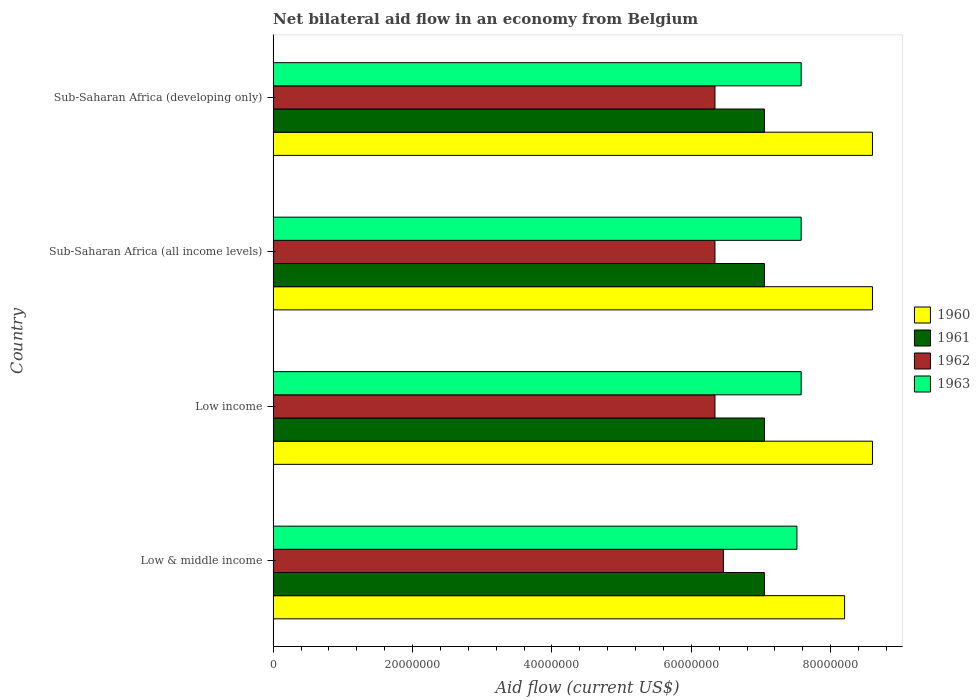How many different coloured bars are there?
Offer a terse response. 4. Are the number of bars per tick equal to the number of legend labels?
Offer a very short reply. Yes. Are the number of bars on each tick of the Y-axis equal?
Provide a succinct answer. Yes. How many bars are there on the 4th tick from the top?
Make the answer very short. 4. What is the label of the 1st group of bars from the top?
Your answer should be very brief. Sub-Saharan Africa (developing only). What is the net bilateral aid flow in 1961 in Low & middle income?
Provide a succinct answer. 7.05e+07. Across all countries, what is the maximum net bilateral aid flow in 1961?
Your response must be concise. 7.05e+07. Across all countries, what is the minimum net bilateral aid flow in 1960?
Offer a terse response. 8.20e+07. In which country was the net bilateral aid flow in 1962 maximum?
Provide a succinct answer. Low & middle income. In which country was the net bilateral aid flow in 1960 minimum?
Provide a succinct answer. Low & middle income. What is the total net bilateral aid flow in 1961 in the graph?
Your answer should be very brief. 2.82e+08. What is the difference between the net bilateral aid flow in 1961 in Low & middle income and that in Sub-Saharan Africa (all income levels)?
Your answer should be compact. 0. What is the difference between the net bilateral aid flow in 1961 in Low income and the net bilateral aid flow in 1962 in Low & middle income?
Make the answer very short. 5.89e+06. What is the average net bilateral aid flow in 1963 per country?
Make the answer very short. 7.56e+07. What is the difference between the net bilateral aid flow in 1962 and net bilateral aid flow in 1961 in Sub-Saharan Africa (all income levels)?
Give a very brief answer. -7.10e+06. What is the ratio of the net bilateral aid flow in 1963 in Low & middle income to that in Sub-Saharan Africa (developing only)?
Your response must be concise. 0.99. Is the net bilateral aid flow in 1962 in Sub-Saharan Africa (all income levels) less than that in Sub-Saharan Africa (developing only)?
Keep it short and to the point. No. Is the difference between the net bilateral aid flow in 1962 in Low income and Sub-Saharan Africa (developing only) greater than the difference between the net bilateral aid flow in 1961 in Low income and Sub-Saharan Africa (developing only)?
Make the answer very short. No. What is the difference between the highest and the second highest net bilateral aid flow in 1962?
Offer a terse response. 1.21e+06. What is the difference between the highest and the lowest net bilateral aid flow in 1961?
Make the answer very short. 0. In how many countries, is the net bilateral aid flow in 1961 greater than the average net bilateral aid flow in 1961 taken over all countries?
Offer a terse response. 0. Is the sum of the net bilateral aid flow in 1960 in Low income and Sub-Saharan Africa (all income levels) greater than the maximum net bilateral aid flow in 1961 across all countries?
Keep it short and to the point. Yes. Is it the case that in every country, the sum of the net bilateral aid flow in 1963 and net bilateral aid flow in 1961 is greater than the net bilateral aid flow in 1960?
Your answer should be very brief. Yes. How many bars are there?
Offer a very short reply. 16. How many countries are there in the graph?
Offer a terse response. 4. Does the graph contain any zero values?
Ensure brevity in your answer.  No. Does the graph contain grids?
Ensure brevity in your answer.  No. Where does the legend appear in the graph?
Provide a short and direct response. Center right. How are the legend labels stacked?
Your answer should be very brief. Vertical. What is the title of the graph?
Your answer should be very brief. Net bilateral aid flow in an economy from Belgium. Does "1970" appear as one of the legend labels in the graph?
Your response must be concise. No. What is the label or title of the X-axis?
Give a very brief answer. Aid flow (current US$). What is the Aid flow (current US$) of 1960 in Low & middle income?
Keep it short and to the point. 8.20e+07. What is the Aid flow (current US$) in 1961 in Low & middle income?
Make the answer very short. 7.05e+07. What is the Aid flow (current US$) in 1962 in Low & middle income?
Your answer should be very brief. 6.46e+07. What is the Aid flow (current US$) of 1963 in Low & middle income?
Keep it short and to the point. 7.52e+07. What is the Aid flow (current US$) in 1960 in Low income?
Make the answer very short. 8.60e+07. What is the Aid flow (current US$) of 1961 in Low income?
Make the answer very short. 7.05e+07. What is the Aid flow (current US$) of 1962 in Low income?
Offer a terse response. 6.34e+07. What is the Aid flow (current US$) of 1963 in Low income?
Keep it short and to the point. 7.58e+07. What is the Aid flow (current US$) of 1960 in Sub-Saharan Africa (all income levels)?
Your answer should be very brief. 8.60e+07. What is the Aid flow (current US$) in 1961 in Sub-Saharan Africa (all income levels)?
Give a very brief answer. 7.05e+07. What is the Aid flow (current US$) of 1962 in Sub-Saharan Africa (all income levels)?
Your response must be concise. 6.34e+07. What is the Aid flow (current US$) of 1963 in Sub-Saharan Africa (all income levels)?
Your response must be concise. 7.58e+07. What is the Aid flow (current US$) of 1960 in Sub-Saharan Africa (developing only)?
Ensure brevity in your answer.  8.60e+07. What is the Aid flow (current US$) of 1961 in Sub-Saharan Africa (developing only)?
Provide a short and direct response. 7.05e+07. What is the Aid flow (current US$) of 1962 in Sub-Saharan Africa (developing only)?
Ensure brevity in your answer.  6.34e+07. What is the Aid flow (current US$) of 1963 in Sub-Saharan Africa (developing only)?
Make the answer very short. 7.58e+07. Across all countries, what is the maximum Aid flow (current US$) in 1960?
Make the answer very short. 8.60e+07. Across all countries, what is the maximum Aid flow (current US$) of 1961?
Your answer should be very brief. 7.05e+07. Across all countries, what is the maximum Aid flow (current US$) of 1962?
Provide a short and direct response. 6.46e+07. Across all countries, what is the maximum Aid flow (current US$) in 1963?
Make the answer very short. 7.58e+07. Across all countries, what is the minimum Aid flow (current US$) in 1960?
Offer a terse response. 8.20e+07. Across all countries, what is the minimum Aid flow (current US$) of 1961?
Keep it short and to the point. 7.05e+07. Across all countries, what is the minimum Aid flow (current US$) in 1962?
Ensure brevity in your answer.  6.34e+07. Across all countries, what is the minimum Aid flow (current US$) of 1963?
Keep it short and to the point. 7.52e+07. What is the total Aid flow (current US$) in 1960 in the graph?
Ensure brevity in your answer.  3.40e+08. What is the total Aid flow (current US$) of 1961 in the graph?
Give a very brief answer. 2.82e+08. What is the total Aid flow (current US$) in 1962 in the graph?
Your response must be concise. 2.55e+08. What is the total Aid flow (current US$) of 1963 in the graph?
Your response must be concise. 3.02e+08. What is the difference between the Aid flow (current US$) of 1962 in Low & middle income and that in Low income?
Offer a very short reply. 1.21e+06. What is the difference between the Aid flow (current US$) in 1963 in Low & middle income and that in Low income?
Provide a short and direct response. -6.10e+05. What is the difference between the Aid flow (current US$) in 1960 in Low & middle income and that in Sub-Saharan Africa (all income levels)?
Ensure brevity in your answer.  -4.00e+06. What is the difference between the Aid flow (current US$) of 1962 in Low & middle income and that in Sub-Saharan Africa (all income levels)?
Make the answer very short. 1.21e+06. What is the difference between the Aid flow (current US$) in 1963 in Low & middle income and that in Sub-Saharan Africa (all income levels)?
Your answer should be compact. -6.10e+05. What is the difference between the Aid flow (current US$) of 1960 in Low & middle income and that in Sub-Saharan Africa (developing only)?
Provide a short and direct response. -4.00e+06. What is the difference between the Aid flow (current US$) of 1961 in Low & middle income and that in Sub-Saharan Africa (developing only)?
Your response must be concise. 0. What is the difference between the Aid flow (current US$) in 1962 in Low & middle income and that in Sub-Saharan Africa (developing only)?
Your answer should be very brief. 1.21e+06. What is the difference between the Aid flow (current US$) of 1963 in Low & middle income and that in Sub-Saharan Africa (developing only)?
Give a very brief answer. -6.10e+05. What is the difference between the Aid flow (current US$) in 1960 in Low income and that in Sub-Saharan Africa (all income levels)?
Your answer should be very brief. 0. What is the difference between the Aid flow (current US$) in 1961 in Low income and that in Sub-Saharan Africa (all income levels)?
Offer a terse response. 0. What is the difference between the Aid flow (current US$) of 1962 in Low income and that in Sub-Saharan Africa (all income levels)?
Your answer should be compact. 0. What is the difference between the Aid flow (current US$) in 1960 in Low income and that in Sub-Saharan Africa (developing only)?
Your response must be concise. 0. What is the difference between the Aid flow (current US$) in 1961 in Low income and that in Sub-Saharan Africa (developing only)?
Your answer should be very brief. 0. What is the difference between the Aid flow (current US$) in 1963 in Low income and that in Sub-Saharan Africa (developing only)?
Your response must be concise. 0. What is the difference between the Aid flow (current US$) of 1960 in Sub-Saharan Africa (all income levels) and that in Sub-Saharan Africa (developing only)?
Your response must be concise. 0. What is the difference between the Aid flow (current US$) in 1960 in Low & middle income and the Aid flow (current US$) in 1961 in Low income?
Provide a short and direct response. 1.15e+07. What is the difference between the Aid flow (current US$) in 1960 in Low & middle income and the Aid flow (current US$) in 1962 in Low income?
Provide a succinct answer. 1.86e+07. What is the difference between the Aid flow (current US$) in 1960 in Low & middle income and the Aid flow (current US$) in 1963 in Low income?
Offer a terse response. 6.23e+06. What is the difference between the Aid flow (current US$) in 1961 in Low & middle income and the Aid flow (current US$) in 1962 in Low income?
Provide a succinct answer. 7.10e+06. What is the difference between the Aid flow (current US$) of 1961 in Low & middle income and the Aid flow (current US$) of 1963 in Low income?
Your answer should be very brief. -5.27e+06. What is the difference between the Aid flow (current US$) in 1962 in Low & middle income and the Aid flow (current US$) in 1963 in Low income?
Offer a terse response. -1.12e+07. What is the difference between the Aid flow (current US$) of 1960 in Low & middle income and the Aid flow (current US$) of 1961 in Sub-Saharan Africa (all income levels)?
Your response must be concise. 1.15e+07. What is the difference between the Aid flow (current US$) of 1960 in Low & middle income and the Aid flow (current US$) of 1962 in Sub-Saharan Africa (all income levels)?
Provide a short and direct response. 1.86e+07. What is the difference between the Aid flow (current US$) of 1960 in Low & middle income and the Aid flow (current US$) of 1963 in Sub-Saharan Africa (all income levels)?
Ensure brevity in your answer.  6.23e+06. What is the difference between the Aid flow (current US$) in 1961 in Low & middle income and the Aid flow (current US$) in 1962 in Sub-Saharan Africa (all income levels)?
Ensure brevity in your answer.  7.10e+06. What is the difference between the Aid flow (current US$) of 1961 in Low & middle income and the Aid flow (current US$) of 1963 in Sub-Saharan Africa (all income levels)?
Your answer should be compact. -5.27e+06. What is the difference between the Aid flow (current US$) of 1962 in Low & middle income and the Aid flow (current US$) of 1963 in Sub-Saharan Africa (all income levels)?
Your answer should be very brief. -1.12e+07. What is the difference between the Aid flow (current US$) of 1960 in Low & middle income and the Aid flow (current US$) of 1961 in Sub-Saharan Africa (developing only)?
Offer a terse response. 1.15e+07. What is the difference between the Aid flow (current US$) of 1960 in Low & middle income and the Aid flow (current US$) of 1962 in Sub-Saharan Africa (developing only)?
Your answer should be compact. 1.86e+07. What is the difference between the Aid flow (current US$) in 1960 in Low & middle income and the Aid flow (current US$) in 1963 in Sub-Saharan Africa (developing only)?
Keep it short and to the point. 6.23e+06. What is the difference between the Aid flow (current US$) of 1961 in Low & middle income and the Aid flow (current US$) of 1962 in Sub-Saharan Africa (developing only)?
Provide a short and direct response. 7.10e+06. What is the difference between the Aid flow (current US$) of 1961 in Low & middle income and the Aid flow (current US$) of 1963 in Sub-Saharan Africa (developing only)?
Offer a terse response. -5.27e+06. What is the difference between the Aid flow (current US$) of 1962 in Low & middle income and the Aid flow (current US$) of 1963 in Sub-Saharan Africa (developing only)?
Your response must be concise. -1.12e+07. What is the difference between the Aid flow (current US$) in 1960 in Low income and the Aid flow (current US$) in 1961 in Sub-Saharan Africa (all income levels)?
Offer a terse response. 1.55e+07. What is the difference between the Aid flow (current US$) of 1960 in Low income and the Aid flow (current US$) of 1962 in Sub-Saharan Africa (all income levels)?
Make the answer very short. 2.26e+07. What is the difference between the Aid flow (current US$) in 1960 in Low income and the Aid flow (current US$) in 1963 in Sub-Saharan Africa (all income levels)?
Your answer should be very brief. 1.02e+07. What is the difference between the Aid flow (current US$) of 1961 in Low income and the Aid flow (current US$) of 1962 in Sub-Saharan Africa (all income levels)?
Provide a short and direct response. 7.10e+06. What is the difference between the Aid flow (current US$) in 1961 in Low income and the Aid flow (current US$) in 1963 in Sub-Saharan Africa (all income levels)?
Provide a short and direct response. -5.27e+06. What is the difference between the Aid flow (current US$) of 1962 in Low income and the Aid flow (current US$) of 1963 in Sub-Saharan Africa (all income levels)?
Make the answer very short. -1.24e+07. What is the difference between the Aid flow (current US$) in 1960 in Low income and the Aid flow (current US$) in 1961 in Sub-Saharan Africa (developing only)?
Make the answer very short. 1.55e+07. What is the difference between the Aid flow (current US$) of 1960 in Low income and the Aid flow (current US$) of 1962 in Sub-Saharan Africa (developing only)?
Provide a succinct answer. 2.26e+07. What is the difference between the Aid flow (current US$) in 1960 in Low income and the Aid flow (current US$) in 1963 in Sub-Saharan Africa (developing only)?
Keep it short and to the point. 1.02e+07. What is the difference between the Aid flow (current US$) of 1961 in Low income and the Aid flow (current US$) of 1962 in Sub-Saharan Africa (developing only)?
Ensure brevity in your answer.  7.10e+06. What is the difference between the Aid flow (current US$) in 1961 in Low income and the Aid flow (current US$) in 1963 in Sub-Saharan Africa (developing only)?
Provide a short and direct response. -5.27e+06. What is the difference between the Aid flow (current US$) in 1962 in Low income and the Aid flow (current US$) in 1963 in Sub-Saharan Africa (developing only)?
Your answer should be very brief. -1.24e+07. What is the difference between the Aid flow (current US$) in 1960 in Sub-Saharan Africa (all income levels) and the Aid flow (current US$) in 1961 in Sub-Saharan Africa (developing only)?
Offer a very short reply. 1.55e+07. What is the difference between the Aid flow (current US$) in 1960 in Sub-Saharan Africa (all income levels) and the Aid flow (current US$) in 1962 in Sub-Saharan Africa (developing only)?
Your response must be concise. 2.26e+07. What is the difference between the Aid flow (current US$) in 1960 in Sub-Saharan Africa (all income levels) and the Aid flow (current US$) in 1963 in Sub-Saharan Africa (developing only)?
Give a very brief answer. 1.02e+07. What is the difference between the Aid flow (current US$) in 1961 in Sub-Saharan Africa (all income levels) and the Aid flow (current US$) in 1962 in Sub-Saharan Africa (developing only)?
Your answer should be very brief. 7.10e+06. What is the difference between the Aid flow (current US$) of 1961 in Sub-Saharan Africa (all income levels) and the Aid flow (current US$) of 1963 in Sub-Saharan Africa (developing only)?
Offer a terse response. -5.27e+06. What is the difference between the Aid flow (current US$) in 1962 in Sub-Saharan Africa (all income levels) and the Aid flow (current US$) in 1963 in Sub-Saharan Africa (developing only)?
Ensure brevity in your answer.  -1.24e+07. What is the average Aid flow (current US$) in 1960 per country?
Ensure brevity in your answer.  8.50e+07. What is the average Aid flow (current US$) of 1961 per country?
Your answer should be compact. 7.05e+07. What is the average Aid flow (current US$) in 1962 per country?
Your response must be concise. 6.37e+07. What is the average Aid flow (current US$) in 1963 per country?
Ensure brevity in your answer.  7.56e+07. What is the difference between the Aid flow (current US$) of 1960 and Aid flow (current US$) of 1961 in Low & middle income?
Provide a succinct answer. 1.15e+07. What is the difference between the Aid flow (current US$) of 1960 and Aid flow (current US$) of 1962 in Low & middle income?
Your answer should be compact. 1.74e+07. What is the difference between the Aid flow (current US$) of 1960 and Aid flow (current US$) of 1963 in Low & middle income?
Offer a terse response. 6.84e+06. What is the difference between the Aid flow (current US$) in 1961 and Aid flow (current US$) in 1962 in Low & middle income?
Keep it short and to the point. 5.89e+06. What is the difference between the Aid flow (current US$) in 1961 and Aid flow (current US$) in 1963 in Low & middle income?
Make the answer very short. -4.66e+06. What is the difference between the Aid flow (current US$) in 1962 and Aid flow (current US$) in 1963 in Low & middle income?
Provide a succinct answer. -1.06e+07. What is the difference between the Aid flow (current US$) of 1960 and Aid flow (current US$) of 1961 in Low income?
Provide a succinct answer. 1.55e+07. What is the difference between the Aid flow (current US$) in 1960 and Aid flow (current US$) in 1962 in Low income?
Keep it short and to the point. 2.26e+07. What is the difference between the Aid flow (current US$) of 1960 and Aid flow (current US$) of 1963 in Low income?
Ensure brevity in your answer.  1.02e+07. What is the difference between the Aid flow (current US$) in 1961 and Aid flow (current US$) in 1962 in Low income?
Give a very brief answer. 7.10e+06. What is the difference between the Aid flow (current US$) of 1961 and Aid flow (current US$) of 1963 in Low income?
Keep it short and to the point. -5.27e+06. What is the difference between the Aid flow (current US$) in 1962 and Aid flow (current US$) in 1963 in Low income?
Provide a short and direct response. -1.24e+07. What is the difference between the Aid flow (current US$) of 1960 and Aid flow (current US$) of 1961 in Sub-Saharan Africa (all income levels)?
Provide a short and direct response. 1.55e+07. What is the difference between the Aid flow (current US$) of 1960 and Aid flow (current US$) of 1962 in Sub-Saharan Africa (all income levels)?
Ensure brevity in your answer.  2.26e+07. What is the difference between the Aid flow (current US$) in 1960 and Aid flow (current US$) in 1963 in Sub-Saharan Africa (all income levels)?
Offer a terse response. 1.02e+07. What is the difference between the Aid flow (current US$) in 1961 and Aid flow (current US$) in 1962 in Sub-Saharan Africa (all income levels)?
Keep it short and to the point. 7.10e+06. What is the difference between the Aid flow (current US$) in 1961 and Aid flow (current US$) in 1963 in Sub-Saharan Africa (all income levels)?
Your answer should be very brief. -5.27e+06. What is the difference between the Aid flow (current US$) of 1962 and Aid flow (current US$) of 1963 in Sub-Saharan Africa (all income levels)?
Provide a short and direct response. -1.24e+07. What is the difference between the Aid flow (current US$) of 1960 and Aid flow (current US$) of 1961 in Sub-Saharan Africa (developing only)?
Your answer should be compact. 1.55e+07. What is the difference between the Aid flow (current US$) in 1960 and Aid flow (current US$) in 1962 in Sub-Saharan Africa (developing only)?
Make the answer very short. 2.26e+07. What is the difference between the Aid flow (current US$) of 1960 and Aid flow (current US$) of 1963 in Sub-Saharan Africa (developing only)?
Keep it short and to the point. 1.02e+07. What is the difference between the Aid flow (current US$) of 1961 and Aid flow (current US$) of 1962 in Sub-Saharan Africa (developing only)?
Offer a terse response. 7.10e+06. What is the difference between the Aid flow (current US$) of 1961 and Aid flow (current US$) of 1963 in Sub-Saharan Africa (developing only)?
Provide a succinct answer. -5.27e+06. What is the difference between the Aid flow (current US$) in 1962 and Aid flow (current US$) in 1963 in Sub-Saharan Africa (developing only)?
Make the answer very short. -1.24e+07. What is the ratio of the Aid flow (current US$) in 1960 in Low & middle income to that in Low income?
Provide a short and direct response. 0.95. What is the ratio of the Aid flow (current US$) in 1961 in Low & middle income to that in Low income?
Offer a very short reply. 1. What is the ratio of the Aid flow (current US$) of 1962 in Low & middle income to that in Low income?
Your answer should be very brief. 1.02. What is the ratio of the Aid flow (current US$) in 1960 in Low & middle income to that in Sub-Saharan Africa (all income levels)?
Ensure brevity in your answer.  0.95. What is the ratio of the Aid flow (current US$) of 1962 in Low & middle income to that in Sub-Saharan Africa (all income levels)?
Your answer should be very brief. 1.02. What is the ratio of the Aid flow (current US$) of 1960 in Low & middle income to that in Sub-Saharan Africa (developing only)?
Your answer should be compact. 0.95. What is the ratio of the Aid flow (current US$) in 1962 in Low & middle income to that in Sub-Saharan Africa (developing only)?
Provide a succinct answer. 1.02. What is the ratio of the Aid flow (current US$) in 1960 in Low income to that in Sub-Saharan Africa (all income levels)?
Your response must be concise. 1. What is the ratio of the Aid flow (current US$) in 1962 in Low income to that in Sub-Saharan Africa (all income levels)?
Your response must be concise. 1. What is the ratio of the Aid flow (current US$) in 1963 in Low income to that in Sub-Saharan Africa (all income levels)?
Your response must be concise. 1. What is the ratio of the Aid flow (current US$) in 1961 in Low income to that in Sub-Saharan Africa (developing only)?
Give a very brief answer. 1. What is the ratio of the Aid flow (current US$) of 1963 in Low income to that in Sub-Saharan Africa (developing only)?
Offer a terse response. 1. What is the ratio of the Aid flow (current US$) of 1963 in Sub-Saharan Africa (all income levels) to that in Sub-Saharan Africa (developing only)?
Your response must be concise. 1. What is the difference between the highest and the second highest Aid flow (current US$) of 1960?
Offer a terse response. 0. What is the difference between the highest and the second highest Aid flow (current US$) of 1961?
Make the answer very short. 0. What is the difference between the highest and the second highest Aid flow (current US$) of 1962?
Your answer should be very brief. 1.21e+06. What is the difference between the highest and the lowest Aid flow (current US$) in 1962?
Give a very brief answer. 1.21e+06. 